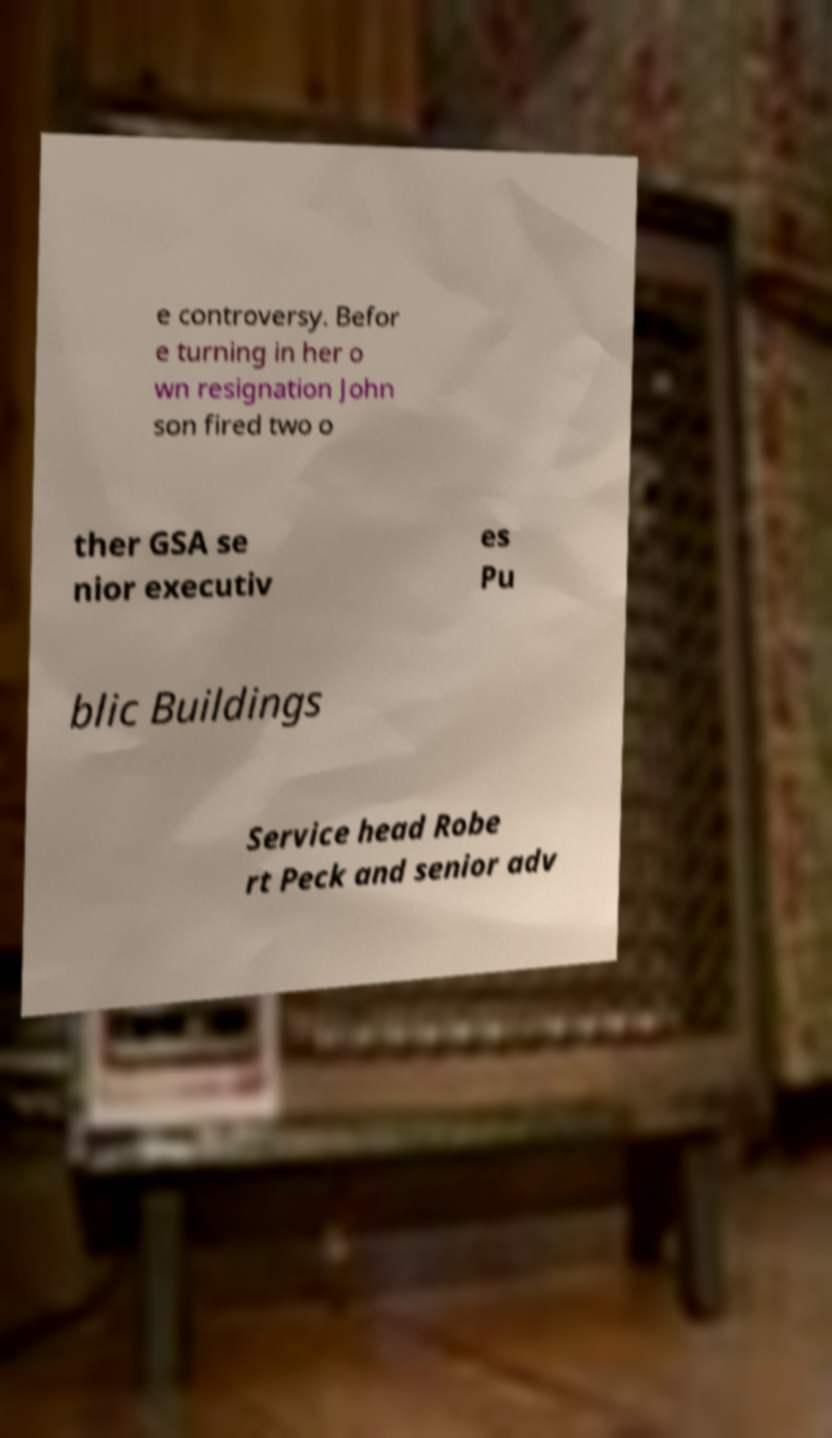Could you extract and type out the text from this image? e controversy. Befor e turning in her o wn resignation John son fired two o ther GSA se nior executiv es Pu blic Buildings Service head Robe rt Peck and senior adv 